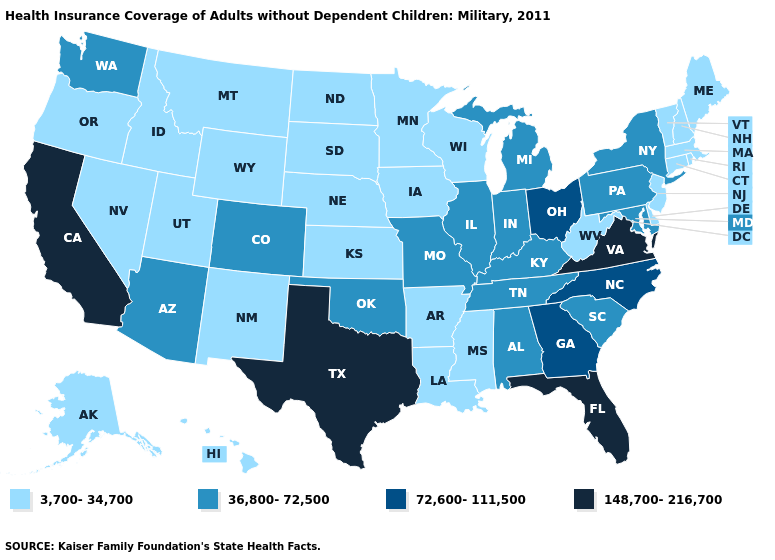Which states have the lowest value in the MidWest?
Short answer required. Iowa, Kansas, Minnesota, Nebraska, North Dakota, South Dakota, Wisconsin. What is the highest value in the USA?
Be succinct. 148,700-216,700. What is the highest value in states that border Georgia?
Short answer required. 148,700-216,700. What is the value of Maine?
Write a very short answer. 3,700-34,700. What is the value of Washington?
Concise answer only. 36,800-72,500. Which states have the highest value in the USA?
Concise answer only. California, Florida, Texas, Virginia. What is the highest value in the USA?
Concise answer only. 148,700-216,700. Which states have the lowest value in the USA?
Write a very short answer. Alaska, Arkansas, Connecticut, Delaware, Hawaii, Idaho, Iowa, Kansas, Louisiana, Maine, Massachusetts, Minnesota, Mississippi, Montana, Nebraska, Nevada, New Hampshire, New Jersey, New Mexico, North Dakota, Oregon, Rhode Island, South Dakota, Utah, Vermont, West Virginia, Wisconsin, Wyoming. Name the states that have a value in the range 3,700-34,700?
Answer briefly. Alaska, Arkansas, Connecticut, Delaware, Hawaii, Idaho, Iowa, Kansas, Louisiana, Maine, Massachusetts, Minnesota, Mississippi, Montana, Nebraska, Nevada, New Hampshire, New Jersey, New Mexico, North Dakota, Oregon, Rhode Island, South Dakota, Utah, Vermont, West Virginia, Wisconsin, Wyoming. Name the states that have a value in the range 3,700-34,700?
Answer briefly. Alaska, Arkansas, Connecticut, Delaware, Hawaii, Idaho, Iowa, Kansas, Louisiana, Maine, Massachusetts, Minnesota, Mississippi, Montana, Nebraska, Nevada, New Hampshire, New Jersey, New Mexico, North Dakota, Oregon, Rhode Island, South Dakota, Utah, Vermont, West Virginia, Wisconsin, Wyoming. Does New Hampshire have the highest value in the USA?
Write a very short answer. No. Among the states that border New York , does Pennsylvania have the highest value?
Write a very short answer. Yes. Which states have the highest value in the USA?
Be succinct. California, Florida, Texas, Virginia. Name the states that have a value in the range 72,600-111,500?
Be succinct. Georgia, North Carolina, Ohio. What is the value of New Jersey?
Concise answer only. 3,700-34,700. 